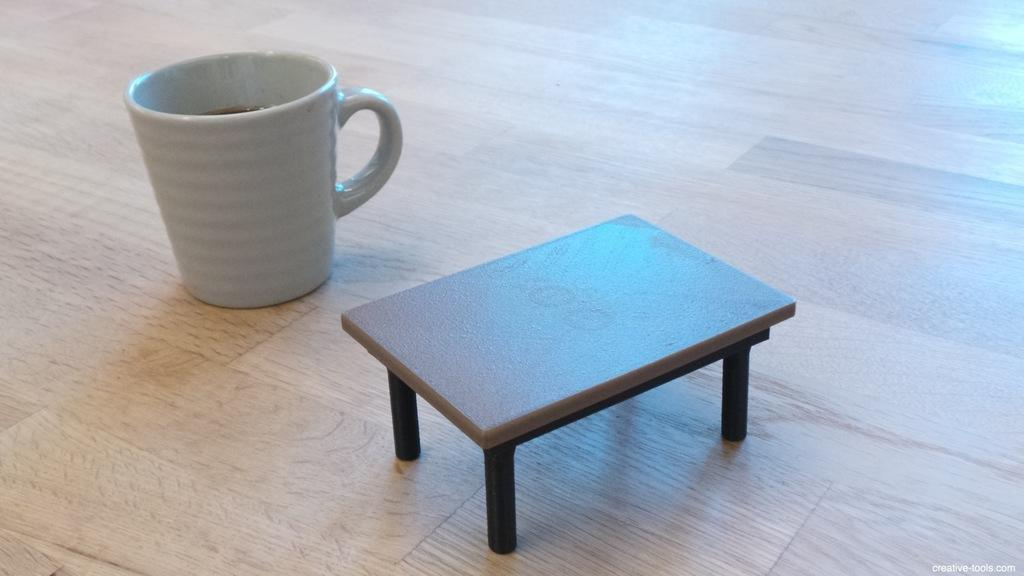What piece of furniture is present in the image? There is a table in the image. Where is the cup located in the image? The cup is on the wooden floor in the image. What is inside the cup? There is a drink in the cup. Can you describe any text visible in the image? Yes, there is text towards the bottom of the image. Can you see any cattle grazing near the lake in the image? There is no lake or cattle present in the image. 